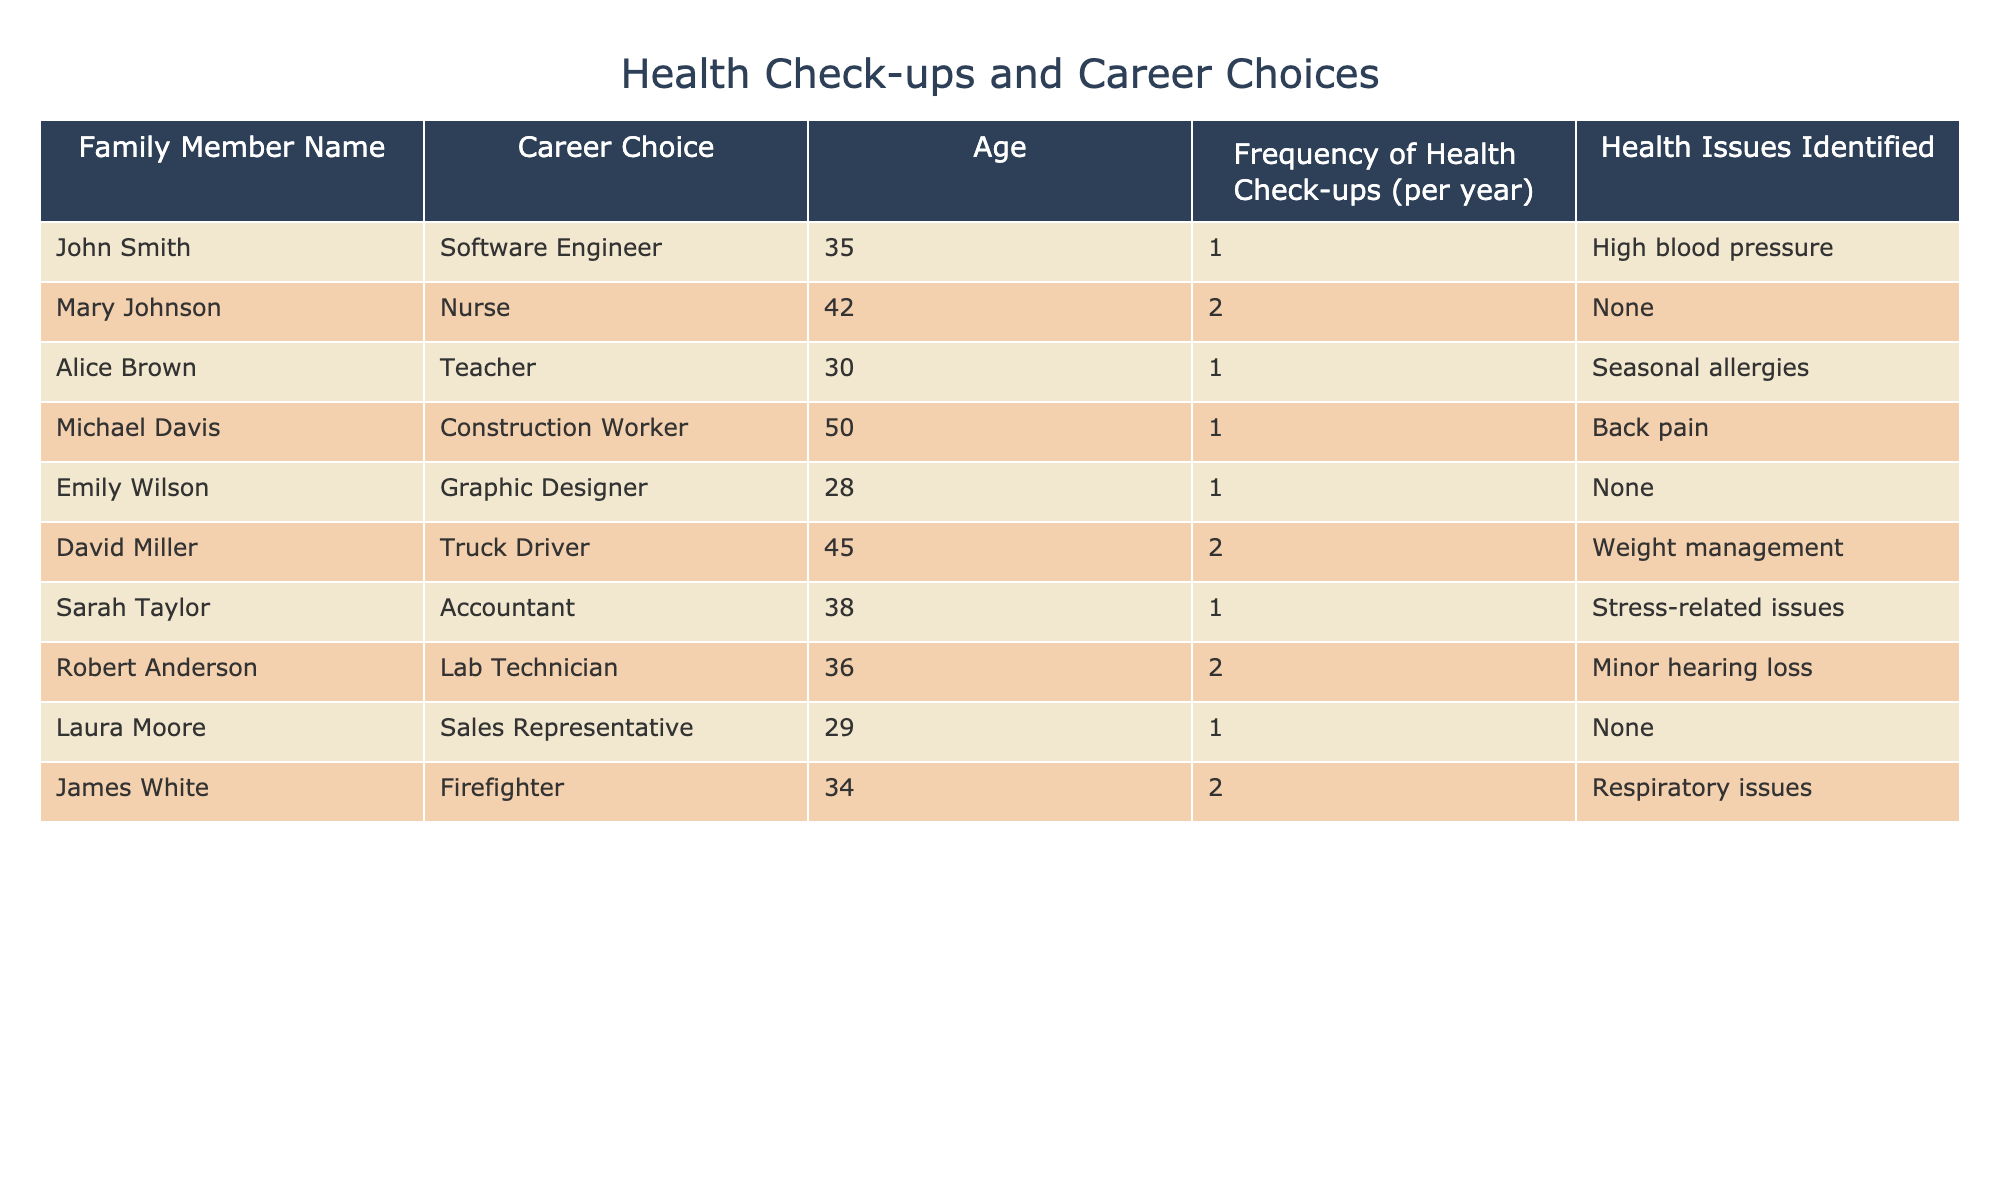What is the frequency of health check-ups for David Miller? David Miller's entry in the table shows that he has a frequency of health check-ups of 2 per year.
Answer: 2 How many family members have identified health issues? In the table, the health issues identified for each family member are noted. Counting the entries with health issues yields 5 members (John Smith, Michael Davis, Sarah Taylor, Robert Anderson, and James White).
Answer: 5 What is the average frequency of health check-ups among the family members? To find the average frequency, we sum the frequencies: 1 + 2 + 1 + 1 + 1 + 2 + 1 + 2 + 1 = 12. There are 9 family members, so the average frequency is 12/9 = 1.33.
Answer: 1.33 Do any family members with health issues have a higher frequency of health check-ups than those without? The individuals with health issues (5 members) have frequencies of 1, 1, 1, 2, and 2, totaling frequencies of 1 and 2. The individuals without health issues (4 members) all have a frequency of 1. Since some members with health issues have a frequency of 2, they indeed have a higher frequency compared to those without health issues.
Answer: Yes Which career choice has the highest frequency of health check-ups? Reviewing the table, two members have a frequency of 2: Mary Johnson (Nurse) and David Miller (Truck Driver), as well as James White (Firefighter). Comparing these frequencies, Nurse has a frequency of 2 but is specifically related to a career choice.
Answer: Nurse, Truck Driver, and Firefighter How many family members work in a healthcare-related career (like Nursing or Lab Technician), and what is their average frequency of health check-ups? The healthcare-related careers include Nurse and Lab Technician. Their frequencies are 2 (Mary Johnson) and 2 (Robert Anderson). The average frequency for these 2 members is (2 + 2) / 2 = 2.
Answer: 2 members, average frequency 2 Is there a family member who is a Teacher or Graphic Designer that has the same frequency of health check-ups? Both Alice Brown (Teacher) and Emily Wilson (Graphic Designer) have a frequency of 1 for health check-ups, confirming that they both share the same frequency.
Answer: Yes What percentage of family members experience high blood pressure? Among the 9 family members, only one member, John Smith, has been identified with high blood pressure. Thus, the percentage is (1/9) * 100 = 11.11%.
Answer: 11.11% 